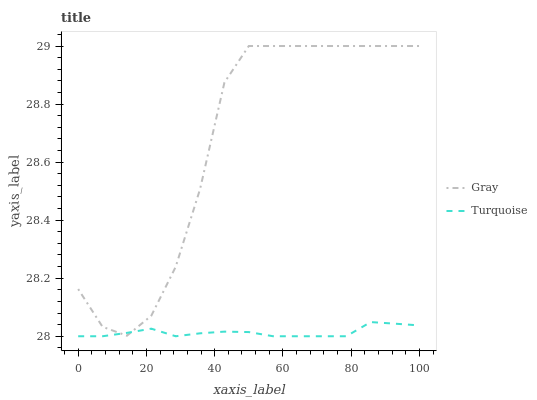Does Turquoise have the maximum area under the curve?
Answer yes or no. No. Is Turquoise the roughest?
Answer yes or no. No. Does Turquoise have the highest value?
Answer yes or no. No. 